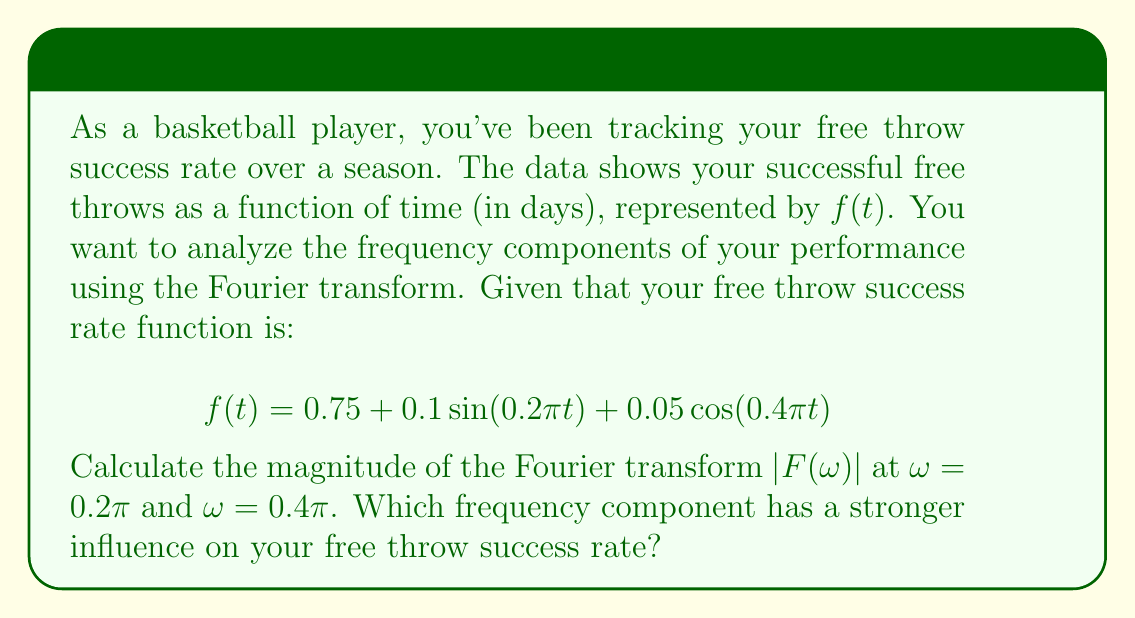What is the answer to this math problem? To solve this problem, we'll follow these steps:

1) Recall the Fourier transform pair for sine and cosine functions:
   $$\mathcal{F}\{\sin(at)\} = \pi[i\delta(\omega+a) - i\delta(\omega-a)]$$
   $$\mathcal{F}\{\cos(at)\} = \pi[\delta(\omega+a) + \delta(\omega-a)]$$

2) The Fourier transform of a constant is:
   $$\mathcal{F}\{0.75\} = 0.75 \cdot 2\pi\delta(\omega)$$

3) Now, let's transform each term of $f(t)$:
   
   For $0.1\sin(0.2\pi t)$:
   $$\mathcal{F}\{0.1\sin(0.2\pi t)\} = 0.1\pi[i\delta(\omega+0.2\pi) - i\delta(\omega-0.2\pi)]$$
   
   For $0.05\cos(0.4\pi t)$:
   $$\mathcal{F}\{0.05\cos(0.4\pi t)\} = 0.05\pi[\delta(\omega+0.4\pi) + \delta(\omega-0.4\pi)]$$

4) The total Fourier transform $F(\omega)$ is the sum of these components:
   $$F(\omega) = 1.5\pi\delta(\omega) + 0.1\pi[i\delta(\omega+0.2\pi) - i\delta(\omega-0.2\pi)] + 0.05\pi[\delta(\omega+0.4\pi) + \delta(\omega-0.4\pi)]$$

5) To find the magnitude at $\omega = 0.2\pi$:
   $|F(0.2\pi)| = |-0.1\pi i| = 0.1\pi$

6) To find the magnitude at $\omega = 0.4\pi$:
   $|F(0.4\pi)| = |0.05\pi| = 0.05\pi$

7) Comparing the magnitudes:
   $|F(0.2\pi)| = 0.1\pi > |F(0.4\pi)| = 0.05\pi$

Therefore, the frequency component at $\omega = 0.2\pi$ has a stronger influence on the free throw success rate.
Answer: The magnitude of the Fourier transform at $\omega = 0.2\pi$ is $0.1\pi$, and at $\omega = 0.4\pi$ is $0.05\pi$. The frequency component at $\omega = 0.2\pi$ has a stronger influence on the free throw success rate. 